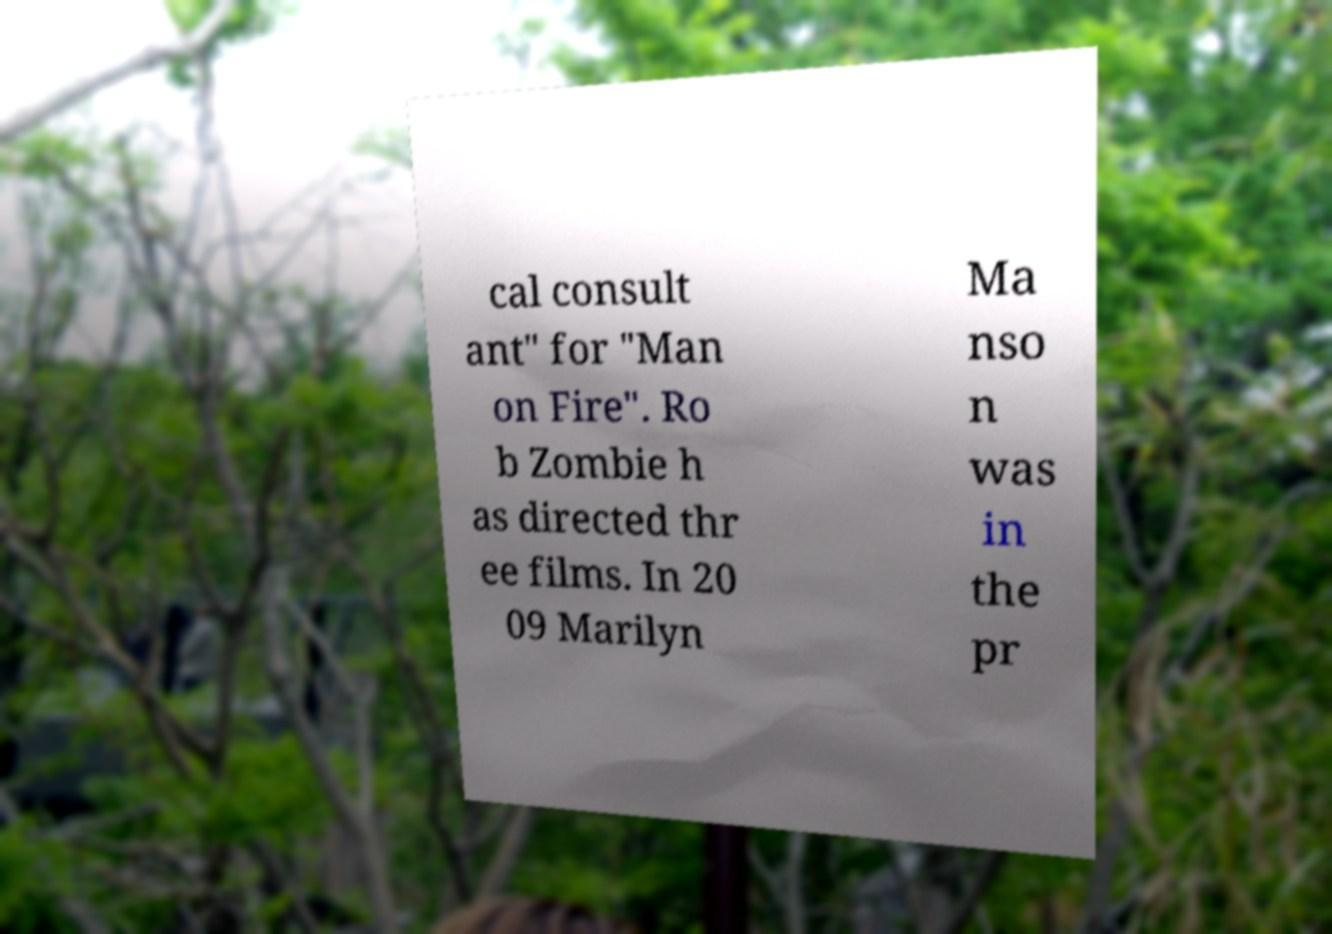Could you extract and type out the text from this image? cal consult ant" for "Man on Fire". Ro b Zombie h as directed thr ee films. In 20 09 Marilyn Ma nso n was in the pr 